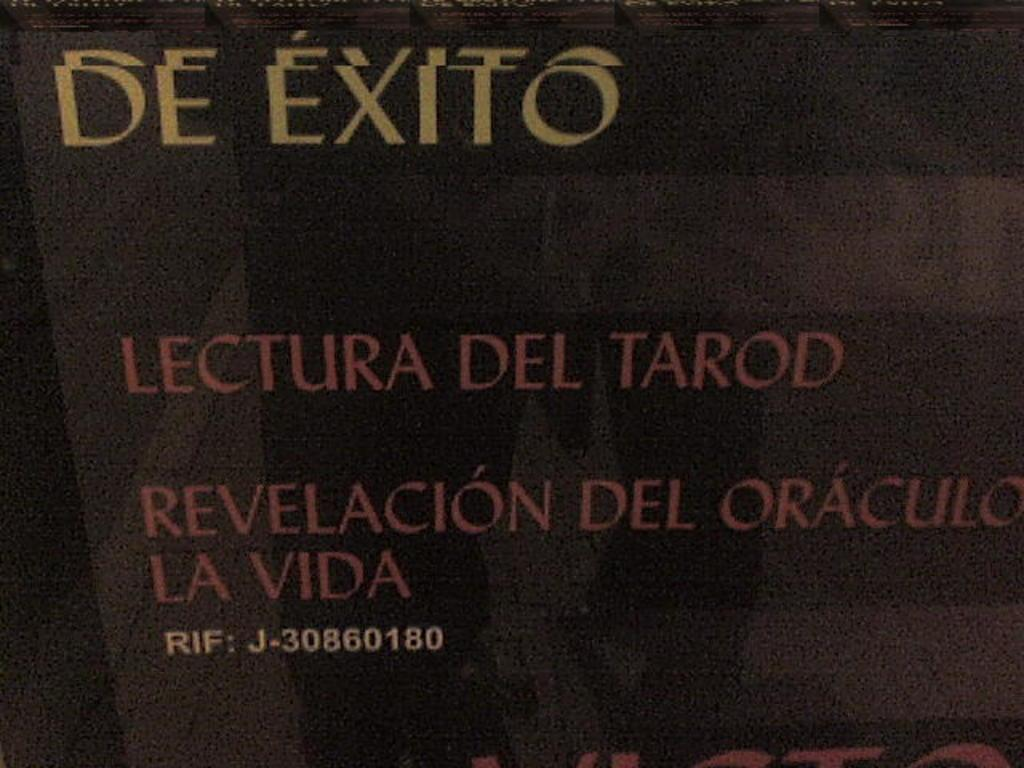What type of image is being described? The image is a poster. What can be found on the poster? There is text on the poster. How many degrees can be seen on the airplane in the image? There is no airplane present in the image, so it is not possible to determine the number of degrees on an airplane. 